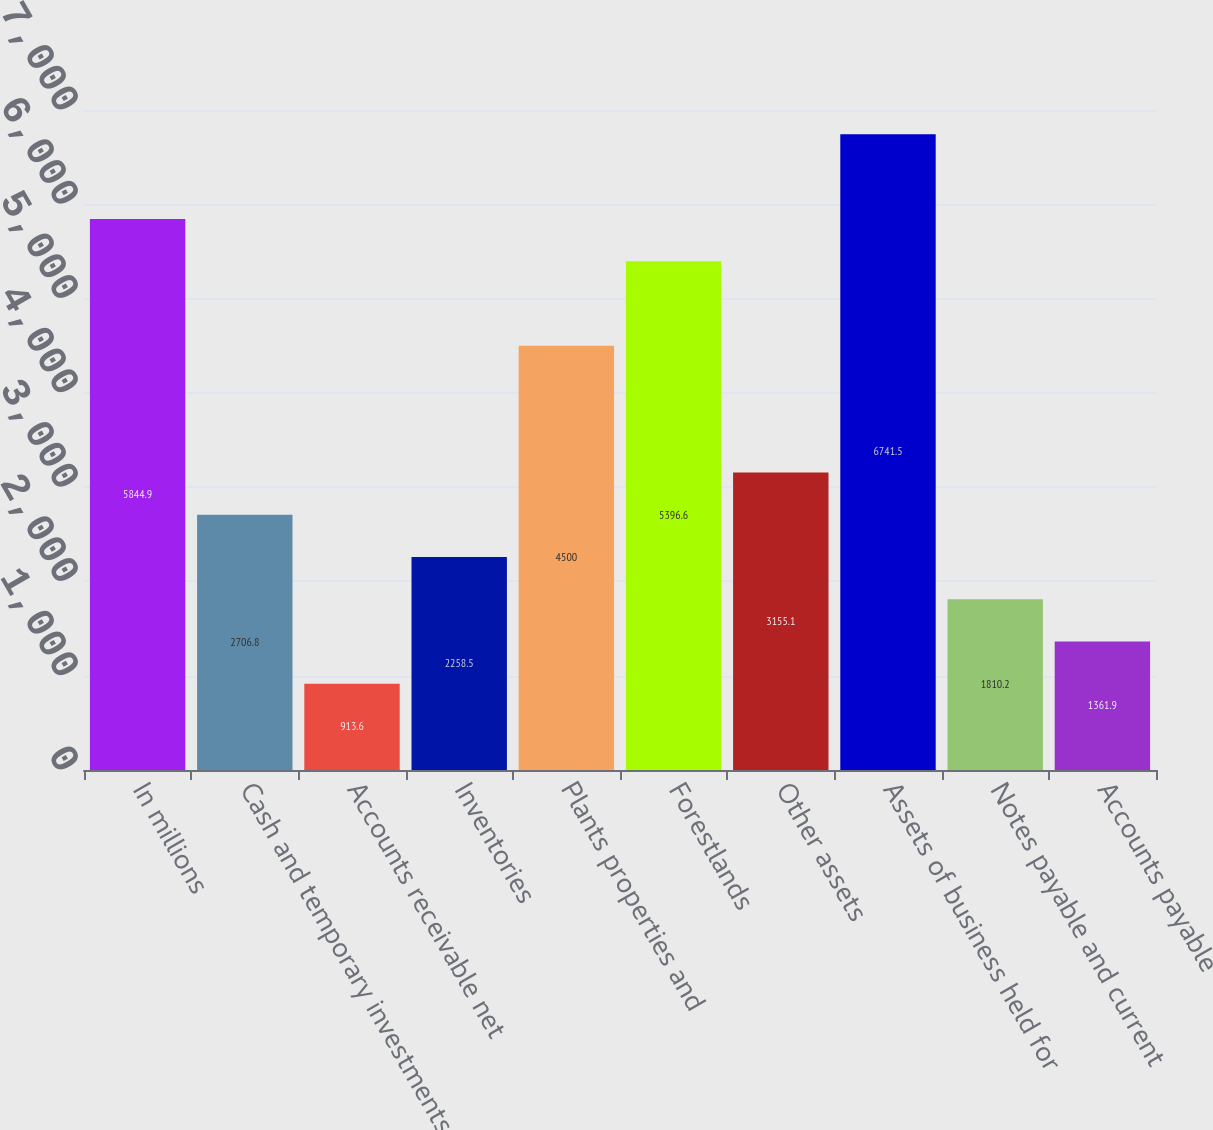Convert chart. <chart><loc_0><loc_0><loc_500><loc_500><bar_chart><fcel>In millions<fcel>Cash and temporary investments<fcel>Accounts receivable net<fcel>Inventories<fcel>Plants properties and<fcel>Forestlands<fcel>Other assets<fcel>Assets of business held for<fcel>Notes payable and current<fcel>Accounts payable<nl><fcel>5844.9<fcel>2706.8<fcel>913.6<fcel>2258.5<fcel>4500<fcel>5396.6<fcel>3155.1<fcel>6741.5<fcel>1810.2<fcel>1361.9<nl></chart> 